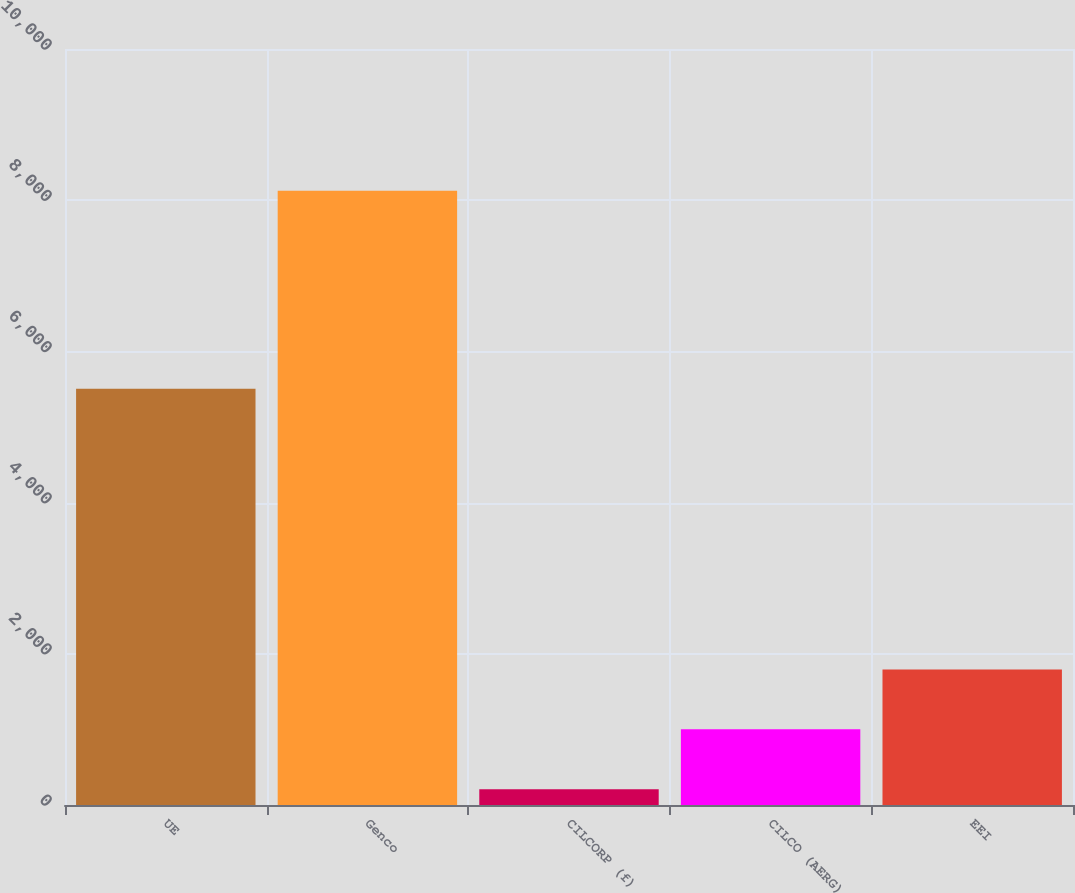<chart> <loc_0><loc_0><loc_500><loc_500><bar_chart><fcel>UE<fcel>Genco<fcel>CILCORP (f)<fcel>CILCO (AERG)<fcel>EEI<nl><fcel>5505<fcel>8125<fcel>209<fcel>1000.6<fcel>1792.2<nl></chart> 